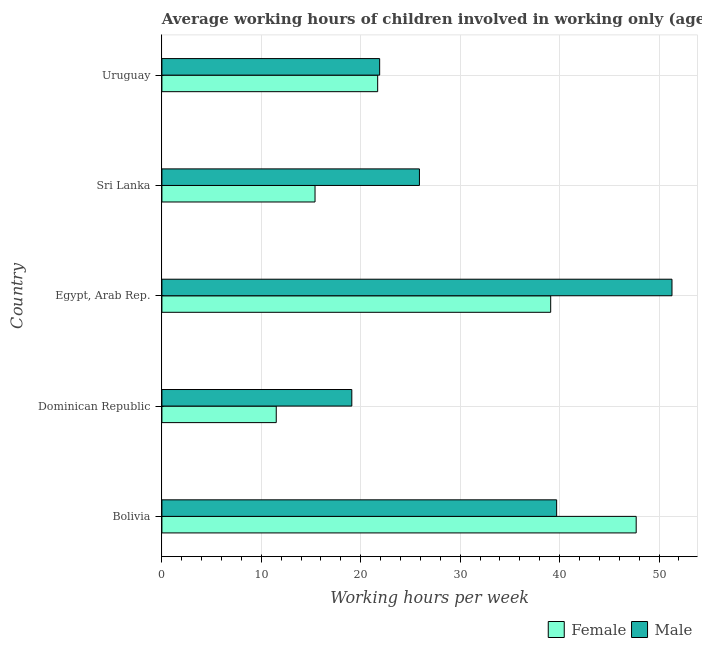How many different coloured bars are there?
Make the answer very short. 2. Are the number of bars on each tick of the Y-axis equal?
Offer a terse response. Yes. How many bars are there on the 5th tick from the bottom?
Your answer should be very brief. 2. What is the label of the 3rd group of bars from the top?
Give a very brief answer. Egypt, Arab Rep. In how many cases, is the number of bars for a given country not equal to the number of legend labels?
Your answer should be compact. 0. Across all countries, what is the maximum average working hour of male children?
Offer a terse response. 51.3. Across all countries, what is the minimum average working hour of male children?
Your answer should be compact. 19.1. In which country was the average working hour of male children maximum?
Your answer should be very brief. Egypt, Arab Rep. In which country was the average working hour of male children minimum?
Offer a terse response. Dominican Republic. What is the total average working hour of female children in the graph?
Make the answer very short. 135.4. What is the difference between the average working hour of female children in Bolivia and that in Sri Lanka?
Keep it short and to the point. 32.3. What is the difference between the average working hour of male children in Bolivia and the average working hour of female children in Uruguay?
Your answer should be very brief. 18. What is the average average working hour of male children per country?
Provide a short and direct response. 31.58. What is the difference between the average working hour of female children and average working hour of male children in Sri Lanka?
Keep it short and to the point. -10.5. What is the ratio of the average working hour of male children in Bolivia to that in Uruguay?
Ensure brevity in your answer.  1.81. Is the difference between the average working hour of male children in Dominican Republic and Egypt, Arab Rep. greater than the difference between the average working hour of female children in Dominican Republic and Egypt, Arab Rep.?
Make the answer very short. No. What is the difference between the highest and the lowest average working hour of male children?
Provide a succinct answer. 32.2. In how many countries, is the average working hour of female children greater than the average average working hour of female children taken over all countries?
Offer a terse response. 2. What does the 2nd bar from the top in Uruguay represents?
Give a very brief answer. Female. Are all the bars in the graph horizontal?
Make the answer very short. Yes. What is the difference between two consecutive major ticks on the X-axis?
Your response must be concise. 10. Does the graph contain grids?
Make the answer very short. Yes. How many legend labels are there?
Your response must be concise. 2. How are the legend labels stacked?
Provide a succinct answer. Horizontal. What is the title of the graph?
Keep it short and to the point. Average working hours of children involved in working only (ages 7-14) in 2009. What is the label or title of the X-axis?
Ensure brevity in your answer.  Working hours per week. What is the label or title of the Y-axis?
Offer a very short reply. Country. What is the Working hours per week in Female in Bolivia?
Provide a short and direct response. 47.7. What is the Working hours per week of Male in Bolivia?
Ensure brevity in your answer.  39.7. What is the Working hours per week in Female in Dominican Republic?
Your response must be concise. 11.5. What is the Working hours per week of Male in Dominican Republic?
Your response must be concise. 19.1. What is the Working hours per week in Female in Egypt, Arab Rep.?
Your answer should be compact. 39.1. What is the Working hours per week of Male in Egypt, Arab Rep.?
Provide a short and direct response. 51.3. What is the Working hours per week of Male in Sri Lanka?
Your answer should be very brief. 25.9. What is the Working hours per week in Female in Uruguay?
Keep it short and to the point. 21.7. What is the Working hours per week in Male in Uruguay?
Your answer should be compact. 21.9. Across all countries, what is the maximum Working hours per week in Female?
Your answer should be very brief. 47.7. Across all countries, what is the maximum Working hours per week in Male?
Give a very brief answer. 51.3. Across all countries, what is the minimum Working hours per week of Female?
Your answer should be compact. 11.5. What is the total Working hours per week of Female in the graph?
Give a very brief answer. 135.4. What is the total Working hours per week in Male in the graph?
Provide a succinct answer. 157.9. What is the difference between the Working hours per week in Female in Bolivia and that in Dominican Republic?
Your answer should be very brief. 36.2. What is the difference between the Working hours per week in Male in Bolivia and that in Dominican Republic?
Your answer should be very brief. 20.6. What is the difference between the Working hours per week of Female in Bolivia and that in Egypt, Arab Rep.?
Give a very brief answer. 8.6. What is the difference between the Working hours per week of Male in Bolivia and that in Egypt, Arab Rep.?
Your answer should be very brief. -11.6. What is the difference between the Working hours per week of Female in Bolivia and that in Sri Lanka?
Provide a succinct answer. 32.3. What is the difference between the Working hours per week of Male in Bolivia and that in Uruguay?
Provide a succinct answer. 17.8. What is the difference between the Working hours per week in Female in Dominican Republic and that in Egypt, Arab Rep.?
Make the answer very short. -27.6. What is the difference between the Working hours per week in Male in Dominican Republic and that in Egypt, Arab Rep.?
Ensure brevity in your answer.  -32.2. What is the difference between the Working hours per week of Female in Dominican Republic and that in Sri Lanka?
Your answer should be very brief. -3.9. What is the difference between the Working hours per week of Male in Dominican Republic and that in Sri Lanka?
Keep it short and to the point. -6.8. What is the difference between the Working hours per week of Male in Dominican Republic and that in Uruguay?
Offer a very short reply. -2.8. What is the difference between the Working hours per week of Female in Egypt, Arab Rep. and that in Sri Lanka?
Provide a short and direct response. 23.7. What is the difference between the Working hours per week in Male in Egypt, Arab Rep. and that in Sri Lanka?
Provide a short and direct response. 25.4. What is the difference between the Working hours per week of Male in Egypt, Arab Rep. and that in Uruguay?
Keep it short and to the point. 29.4. What is the difference between the Working hours per week in Female in Sri Lanka and that in Uruguay?
Your response must be concise. -6.3. What is the difference between the Working hours per week in Male in Sri Lanka and that in Uruguay?
Offer a very short reply. 4. What is the difference between the Working hours per week in Female in Bolivia and the Working hours per week in Male in Dominican Republic?
Your answer should be compact. 28.6. What is the difference between the Working hours per week of Female in Bolivia and the Working hours per week of Male in Sri Lanka?
Keep it short and to the point. 21.8. What is the difference between the Working hours per week in Female in Bolivia and the Working hours per week in Male in Uruguay?
Keep it short and to the point. 25.8. What is the difference between the Working hours per week in Female in Dominican Republic and the Working hours per week in Male in Egypt, Arab Rep.?
Offer a terse response. -39.8. What is the difference between the Working hours per week in Female in Dominican Republic and the Working hours per week in Male in Sri Lanka?
Ensure brevity in your answer.  -14.4. What is the difference between the Working hours per week in Female in Dominican Republic and the Working hours per week in Male in Uruguay?
Your response must be concise. -10.4. What is the average Working hours per week of Female per country?
Offer a terse response. 27.08. What is the average Working hours per week in Male per country?
Your answer should be compact. 31.58. What is the difference between the Working hours per week of Female and Working hours per week of Male in Egypt, Arab Rep.?
Provide a short and direct response. -12.2. What is the difference between the Working hours per week in Female and Working hours per week in Male in Sri Lanka?
Ensure brevity in your answer.  -10.5. What is the ratio of the Working hours per week of Female in Bolivia to that in Dominican Republic?
Ensure brevity in your answer.  4.15. What is the ratio of the Working hours per week in Male in Bolivia to that in Dominican Republic?
Keep it short and to the point. 2.08. What is the ratio of the Working hours per week of Female in Bolivia to that in Egypt, Arab Rep.?
Your response must be concise. 1.22. What is the ratio of the Working hours per week of Male in Bolivia to that in Egypt, Arab Rep.?
Make the answer very short. 0.77. What is the ratio of the Working hours per week in Female in Bolivia to that in Sri Lanka?
Make the answer very short. 3.1. What is the ratio of the Working hours per week of Male in Bolivia to that in Sri Lanka?
Make the answer very short. 1.53. What is the ratio of the Working hours per week in Female in Bolivia to that in Uruguay?
Offer a terse response. 2.2. What is the ratio of the Working hours per week in Male in Bolivia to that in Uruguay?
Offer a very short reply. 1.81. What is the ratio of the Working hours per week of Female in Dominican Republic to that in Egypt, Arab Rep.?
Keep it short and to the point. 0.29. What is the ratio of the Working hours per week in Male in Dominican Republic to that in Egypt, Arab Rep.?
Give a very brief answer. 0.37. What is the ratio of the Working hours per week in Female in Dominican Republic to that in Sri Lanka?
Offer a very short reply. 0.75. What is the ratio of the Working hours per week in Male in Dominican Republic to that in Sri Lanka?
Offer a very short reply. 0.74. What is the ratio of the Working hours per week in Female in Dominican Republic to that in Uruguay?
Your answer should be compact. 0.53. What is the ratio of the Working hours per week of Male in Dominican Republic to that in Uruguay?
Give a very brief answer. 0.87. What is the ratio of the Working hours per week in Female in Egypt, Arab Rep. to that in Sri Lanka?
Keep it short and to the point. 2.54. What is the ratio of the Working hours per week in Male in Egypt, Arab Rep. to that in Sri Lanka?
Offer a very short reply. 1.98. What is the ratio of the Working hours per week in Female in Egypt, Arab Rep. to that in Uruguay?
Make the answer very short. 1.8. What is the ratio of the Working hours per week of Male in Egypt, Arab Rep. to that in Uruguay?
Offer a very short reply. 2.34. What is the ratio of the Working hours per week of Female in Sri Lanka to that in Uruguay?
Your answer should be compact. 0.71. What is the ratio of the Working hours per week of Male in Sri Lanka to that in Uruguay?
Make the answer very short. 1.18. What is the difference between the highest and the second highest Working hours per week of Female?
Your response must be concise. 8.6. What is the difference between the highest and the second highest Working hours per week in Male?
Your answer should be very brief. 11.6. What is the difference between the highest and the lowest Working hours per week in Female?
Ensure brevity in your answer.  36.2. What is the difference between the highest and the lowest Working hours per week of Male?
Your answer should be compact. 32.2. 